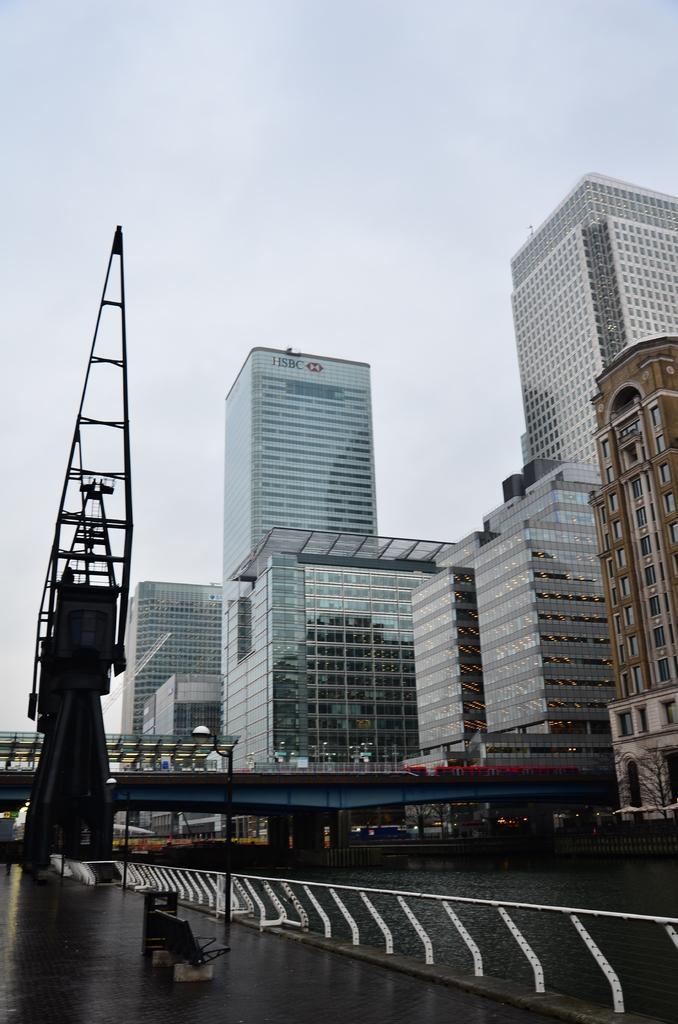Please provide a concise description of this image. In this picture we can see the iron grills, river and a bridge. Behind the bridge there are buildings and the sky. On the building there is a name board. On the left side of the bridge, it looks like an iron object. Behind the buildings there is the sky. 